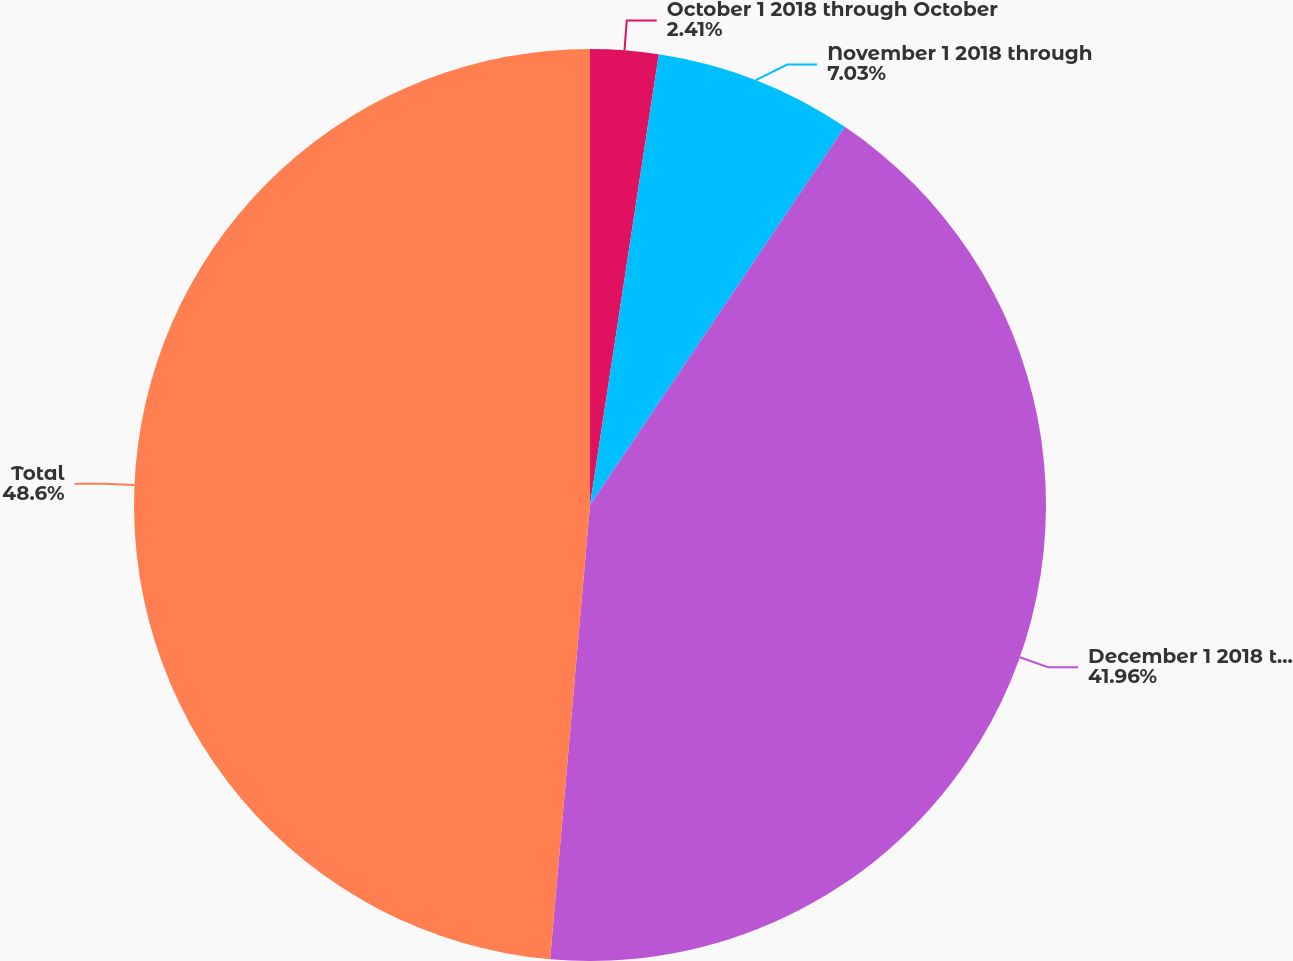Convert chart. <chart><loc_0><loc_0><loc_500><loc_500><pie_chart><fcel>October 1 2018 through October<fcel>November 1 2018 through<fcel>December 1 2018 through<fcel>Total<nl><fcel>2.41%<fcel>7.03%<fcel>41.96%<fcel>48.61%<nl></chart> 